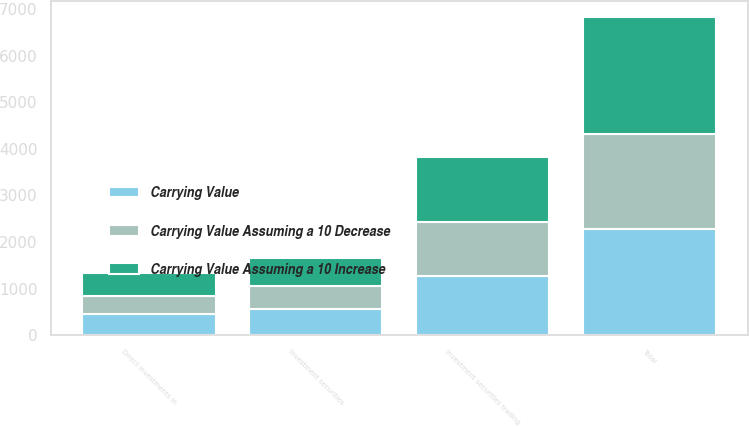Convert chart to OTSL. <chart><loc_0><loc_0><loc_500><loc_500><stacked_bar_chart><ecel><fcel>Investment securities trading<fcel>Investment securities<fcel>Direct investments in<fcel>Total<nl><fcel>Carrying Value<fcel>1277.5<fcel>554.1<fcel>446.1<fcel>2277.7<nl><fcel>Carrying Value Assuming a 10 Increase<fcel>1405.3<fcel>609.5<fcel>490.7<fcel>2505.5<nl><fcel>Carrying Value Assuming a 10 Decrease<fcel>1149.8<fcel>498.7<fcel>401.5<fcel>2050<nl></chart> 